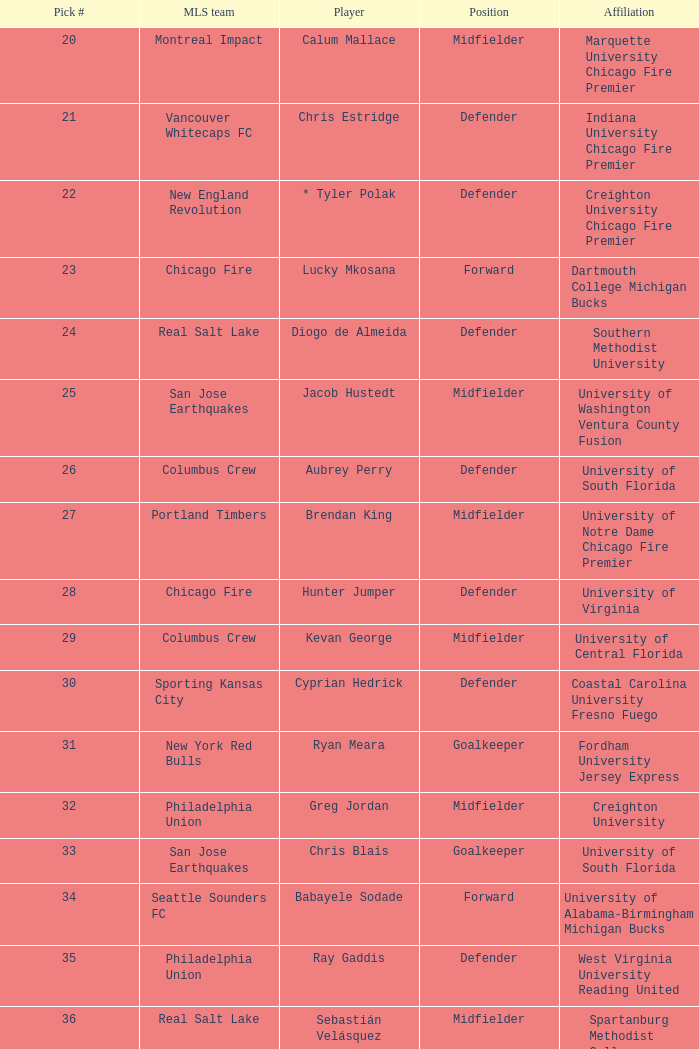What draft number was assigned to real salt lake? 24.0. 